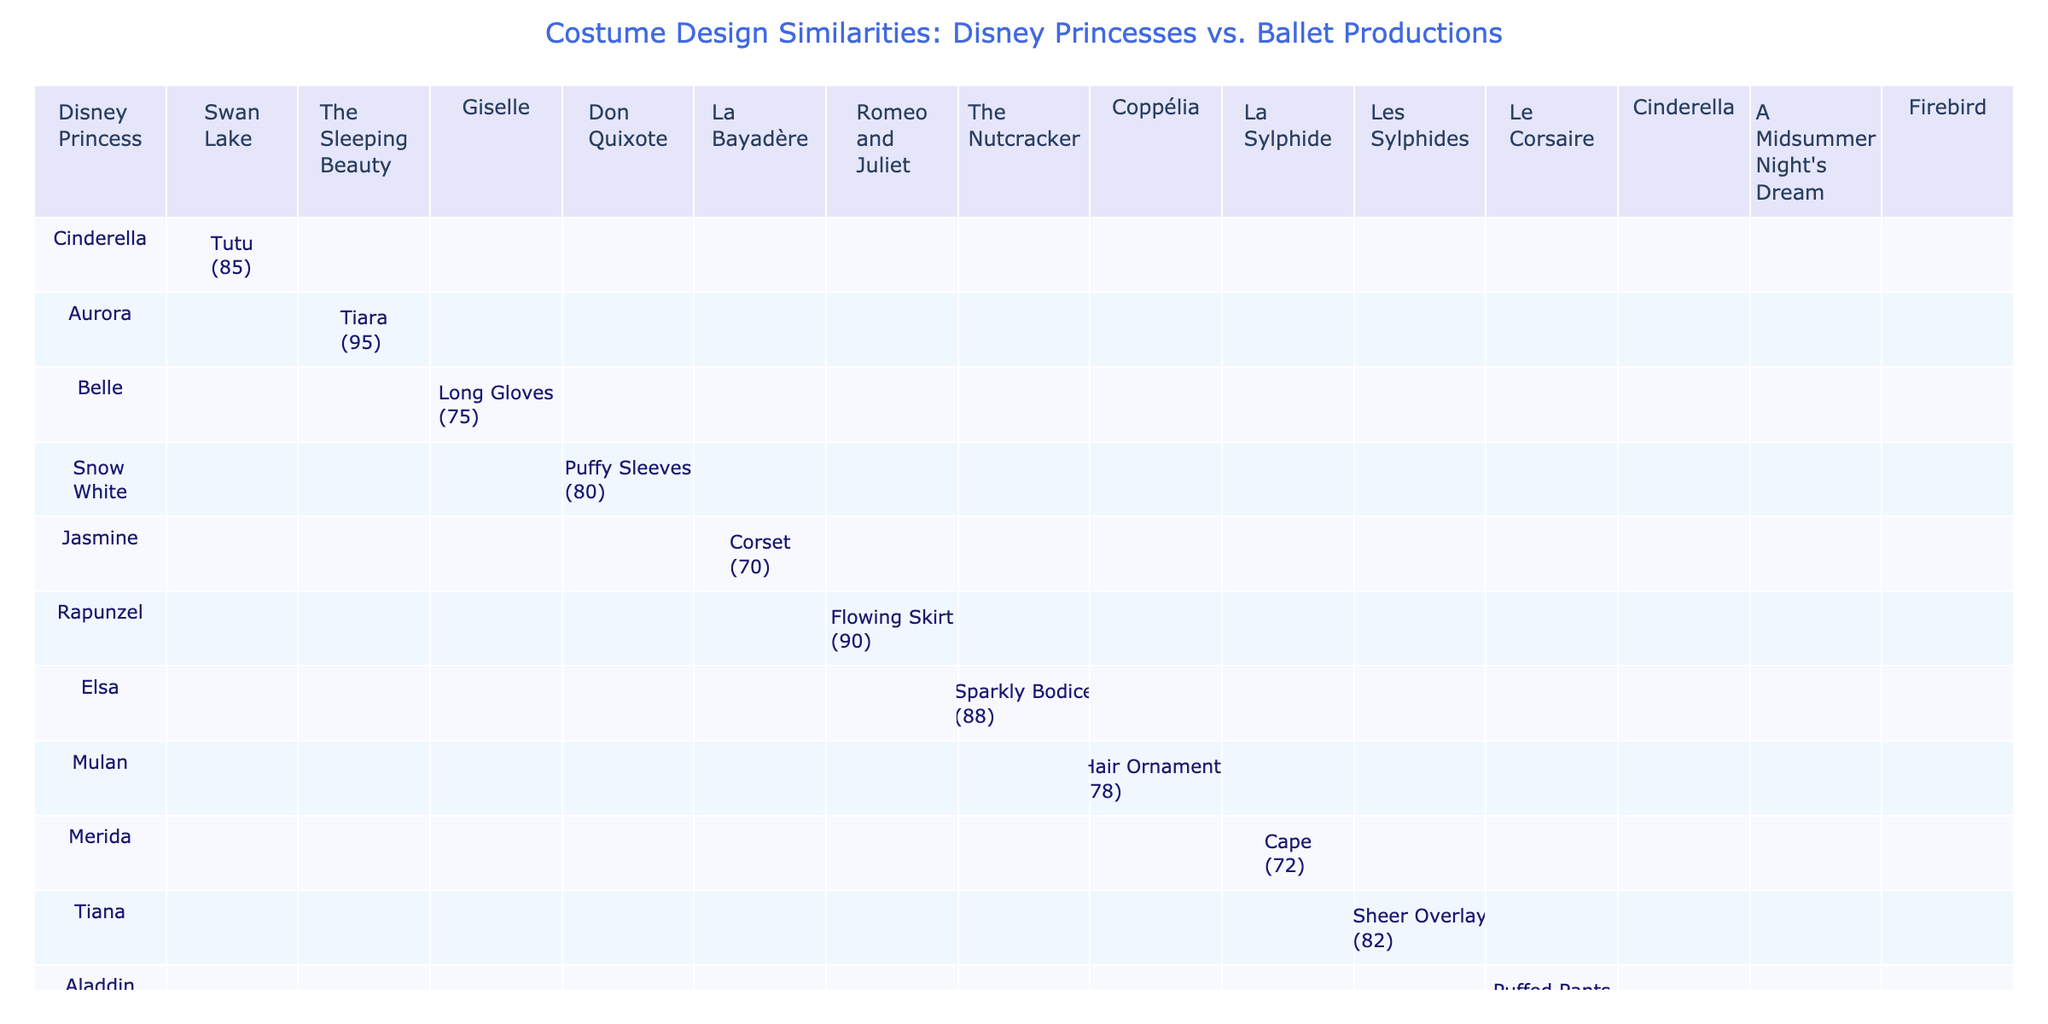What is the highest similarity score for a Disney princess and a ballet production? The highest similarity score in the table is 95, which is between Aurora and The Sleeping Beauty.
Answer: 95 Which Disney princess has a costume design similarity score of 70 or lower? The only Disney princess with a similarity score of 70 or lower is Jasmine with a score of 70 for La Bayadère.
Answer: Jasmine How many costume elements are associated with Ariel and Cinderella in the table? Ariel has one costume element (Jeweled Neckline) related to Cinderella, and Cinderella has one (Tutu), making a total of two costume elements.
Answer: 2 What is the average similarity score for all the similarities involving tutu? There is only one entry for tutu: Cinderella and Swan Lake with a score of 85, so the average is 85/1 = 85.
Answer: 85 True or False: Merida's costume design has a similarity score greater than 80. Merida's score for La Sylphide is 72, which is less than 80.
Answer: False Which ballet production has the highest associated similarity score across all Disney princesses? The Sleeping Beauty, associated with Aurora, has the highest score of 95, making it the ballet production with the highest score.
Answer: The Sleeping Beauty Which Disney princess has the lowest associated similarity score and what is it? Aladdin's Puffed Pants has the lowest associated similarity score of 65.
Answer: 65 What is the total count of unique Disney princesses represented in the table? There are 14 unique Disney princesses listed in the table as seen in the first column.
Answer: 14 If we consider all similarity scores of 80 or higher, how many are there? The scores of 80 or higher are for the following princesses: Aurora (95), Rapunzel (90), Elsa (88), Tiana (82), and Esmeralda (87). This totals to 5 instances.
Answer: 5 What are the common costume elements shared between Disney princesses and ballet productions? Each row indicates specific costume elements associated with both categories, revealing distinct elements like Tutu, Cape, and Hair Ornaments.
Answer: Tutu, Cape, Hair Ornaments 